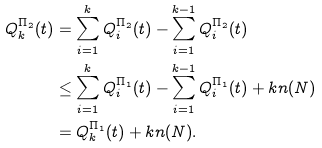<formula> <loc_0><loc_0><loc_500><loc_500>Q _ { k } ^ { \Pi _ { 2 } } ( t ) & = \sum _ { i = 1 } ^ { k } Q _ { i } ^ { \Pi _ { 2 } } ( t ) - \sum _ { i = 1 } ^ { k - 1 } Q _ { i } ^ { \Pi _ { 2 } } ( t ) \\ & \leq \sum _ { i = 1 } ^ { k } Q _ { i } ^ { \Pi _ { 1 } } ( t ) - \sum _ { i = 1 } ^ { k - 1 } Q _ { i } ^ { \Pi _ { 1 } } ( t ) + k n ( N ) \\ & = Q _ { k } ^ { \Pi _ { 1 } } ( t ) + k n ( N ) .</formula> 